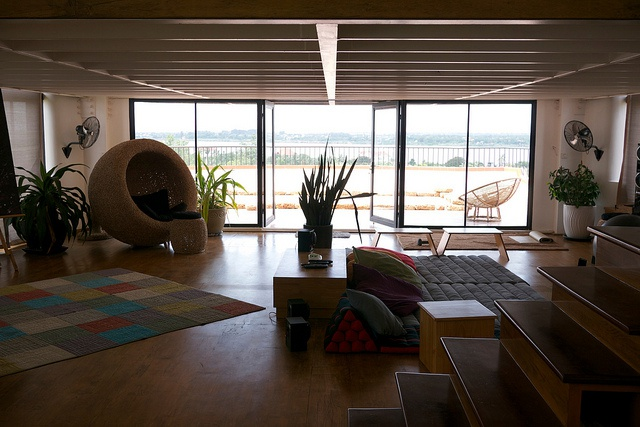Describe the objects in this image and their specific colors. I can see bed in black, gray, and maroon tones, chair in black, maroon, and gray tones, potted plant in black, gray, and darkgray tones, potted plant in black, white, gray, and darkgray tones, and potted plant in black and gray tones in this image. 